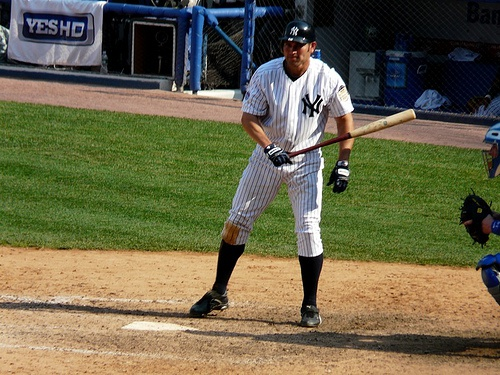Describe the objects in this image and their specific colors. I can see people in black, white, gray, and darkgray tones, people in black, navy, maroon, and darkgreen tones, baseball glove in black, darkgreen, and maroon tones, and baseball bat in black, maroon, and tan tones in this image. 